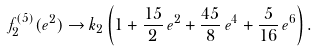<formula> <loc_0><loc_0><loc_500><loc_500>f ^ { ( 5 ) } _ { 2 } ( e ^ { 2 } ) \rightarrow k _ { 2 } \left ( 1 + \frac { 1 5 } { 2 } \, e ^ { 2 } + \frac { 4 5 } { 8 } \, e ^ { 4 } + \frac { 5 } { 1 6 } \, e ^ { 6 } \right ) .</formula> 